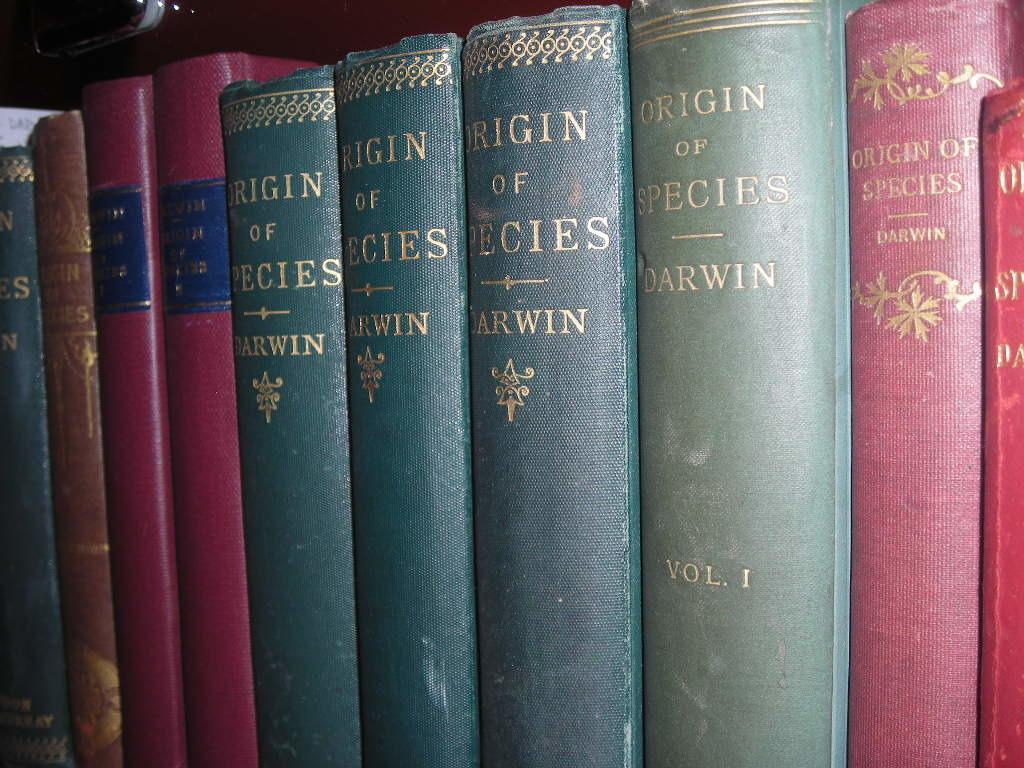<image>
Relay a brief, clear account of the picture shown. old leather bound books like Origin of the Species 